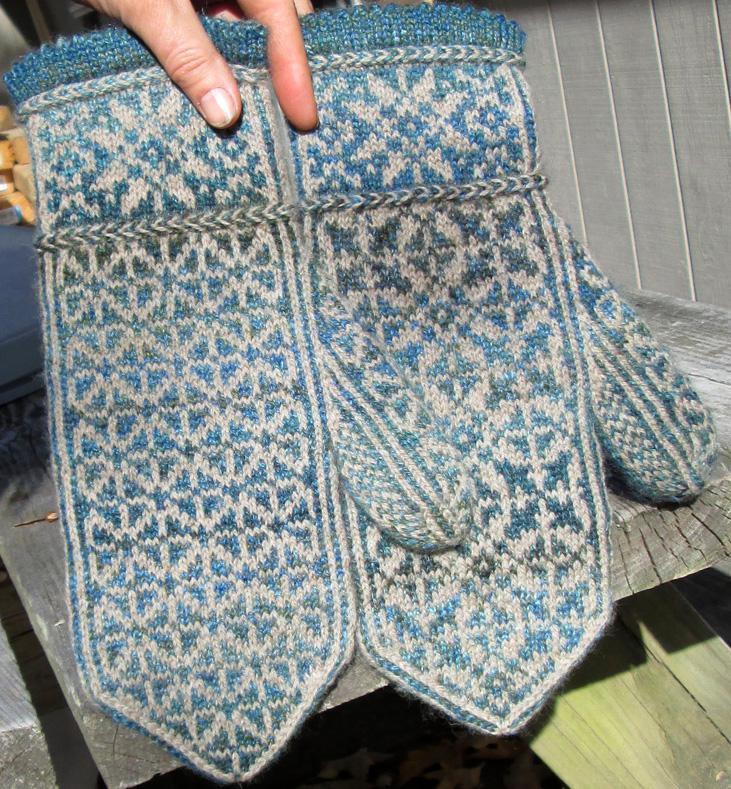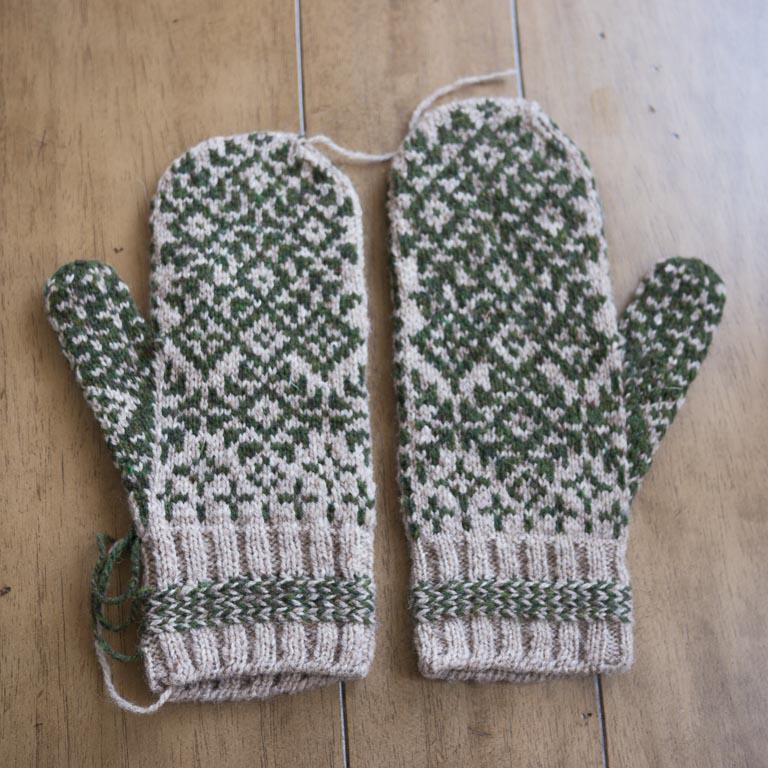The first image is the image on the left, the second image is the image on the right. Examine the images to the left and right. Is the description "At least one pair of mittens features a pointed, triangular shaped top, rather than a rounded one." accurate? Answer yes or no. Yes. The first image is the image on the left, the second image is the image on the right. Assess this claim about the two images: "One image had a clear,wooden background surface.". Correct or not? Answer yes or no. Yes. 